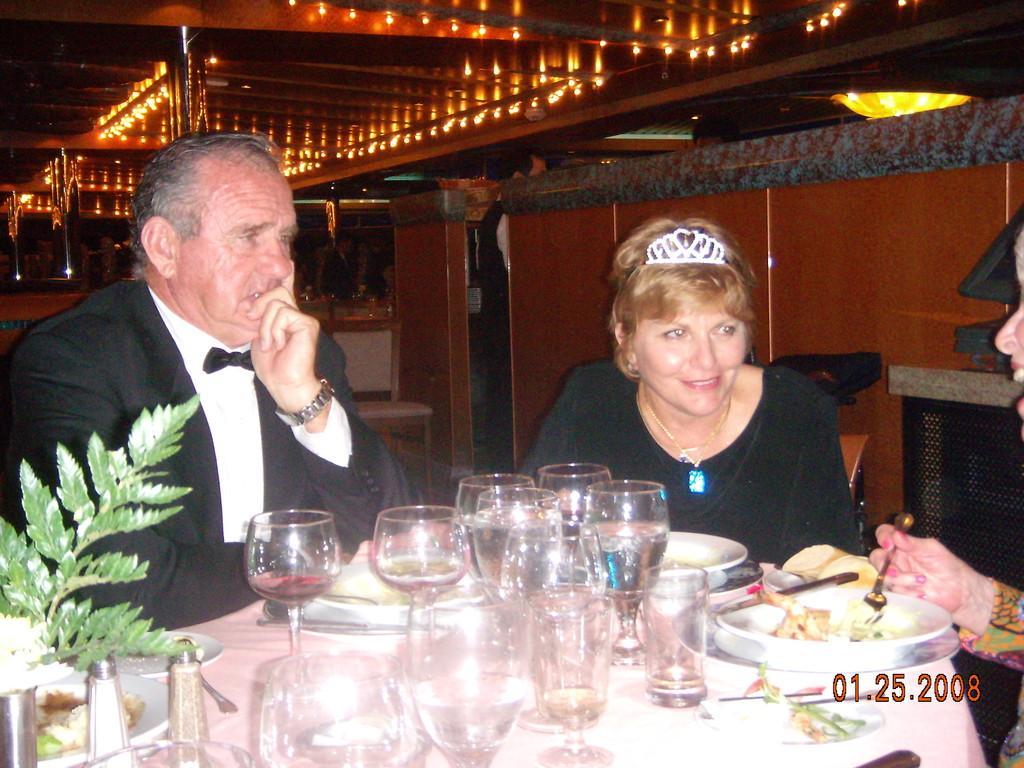Can you describe this image briefly? In this image there is a plant, salt and pepper jars, wine glasses, spoons, forks , knives and plates with food on it on the table, and in the background there are three persons sitting on the chairs, and there are lights and chairs. 